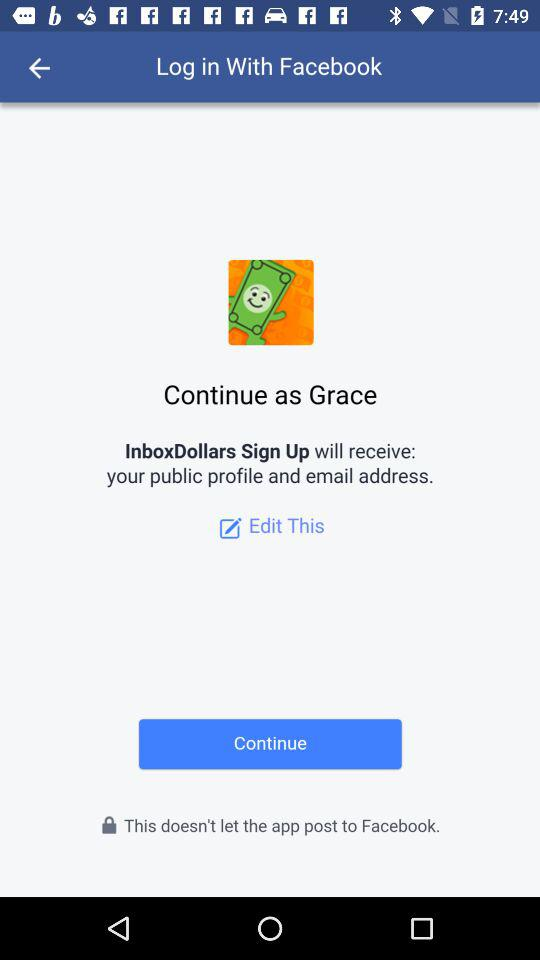What is login name? The login name is Grace. 